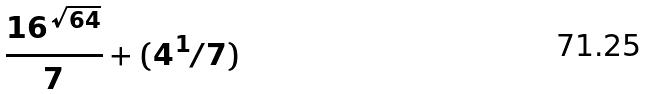Convert formula to latex. <formula><loc_0><loc_0><loc_500><loc_500>\frac { 1 6 ^ { \sqrt { 6 4 } } } { 7 } + ( 4 ^ { 1 } / 7 )</formula> 